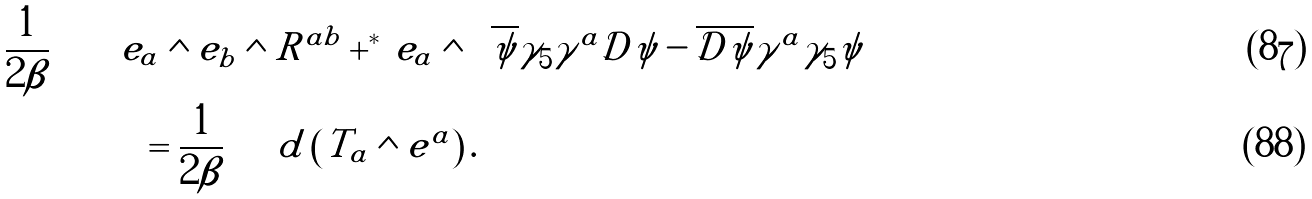Convert formula to latex. <formula><loc_0><loc_0><loc_500><loc_500>\frac { 1 } { 2 \beta } \int & \left [ e _ { a } \wedge e _ { b } \wedge R ^ { a b } + ^ { * } \, e _ { a } \wedge \left ( \overline { \psi } \gamma _ { 5 } \gamma ^ { a } \mathcal { D } \psi - \overline { \mathcal { D } \psi } \gamma ^ { a } \gamma _ { 5 } \psi \right ) \right ] \\ & \quad \ = \frac { 1 } { 2 \beta } \int d \left ( T _ { a } \wedge e ^ { a } \right ) .</formula> 